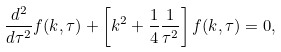<formula> <loc_0><loc_0><loc_500><loc_500>\frac { d ^ { 2 } } { d \tau ^ { 2 } } f ( k , \tau ) + \left [ k ^ { 2 } + \frac { 1 } { 4 } \frac { 1 } { \tau ^ { 2 } } \right ] f ( k , \tau ) = 0 ,</formula> 